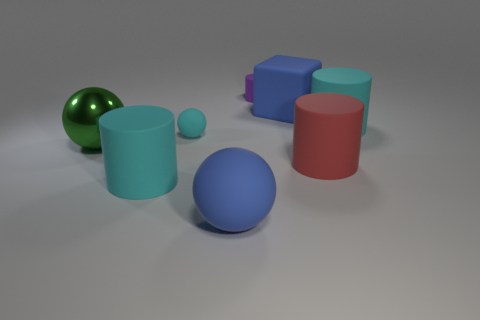Add 1 cylinders. How many objects exist? 9 Subtract all red cylinders. How many cylinders are left? 3 Subtract all purple rubber cylinders. How many cylinders are left? 3 Subtract all balls. How many objects are left? 5 Subtract all purple matte cylinders. Subtract all big rubber cylinders. How many objects are left? 4 Add 6 red things. How many red things are left? 7 Add 7 large matte blocks. How many large matte blocks exist? 8 Subtract 0 purple spheres. How many objects are left? 8 Subtract 1 cylinders. How many cylinders are left? 3 Subtract all purple cubes. Subtract all cyan spheres. How many cubes are left? 1 